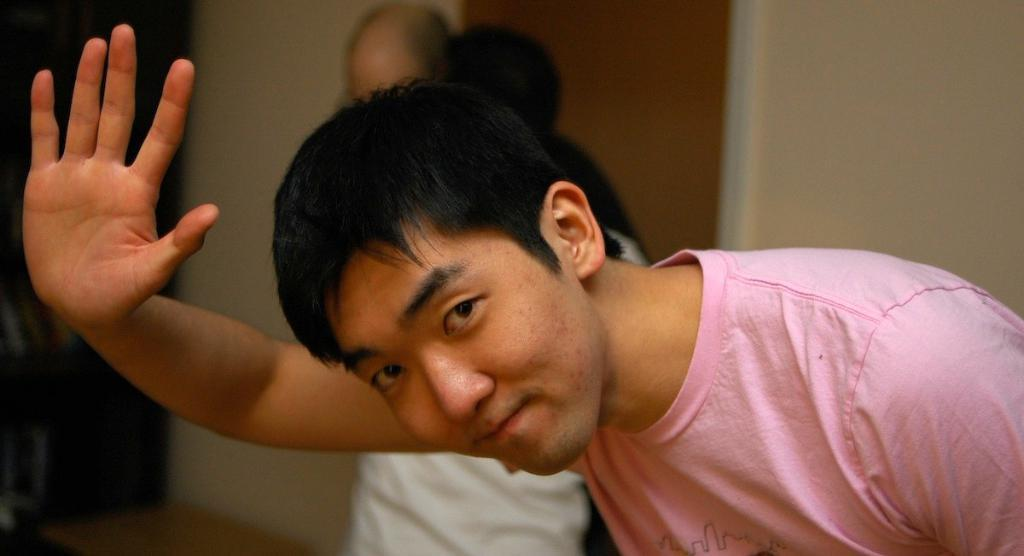What is the man in the image wearing? The man is wearing a pink t-shirt in the image. Can you describe the people in the background of the image? There are two persons in the background of the image. What can be seen behind the man and the two persons? There is a wall visible in the background of the image. How would you describe the appearance of the background? The background appears blurred. What type of stem can be seen growing out of the man's ear in the image? There is no stem or ear visible in the image; it only features a man wearing a pink t-shirt and a blurred background. 